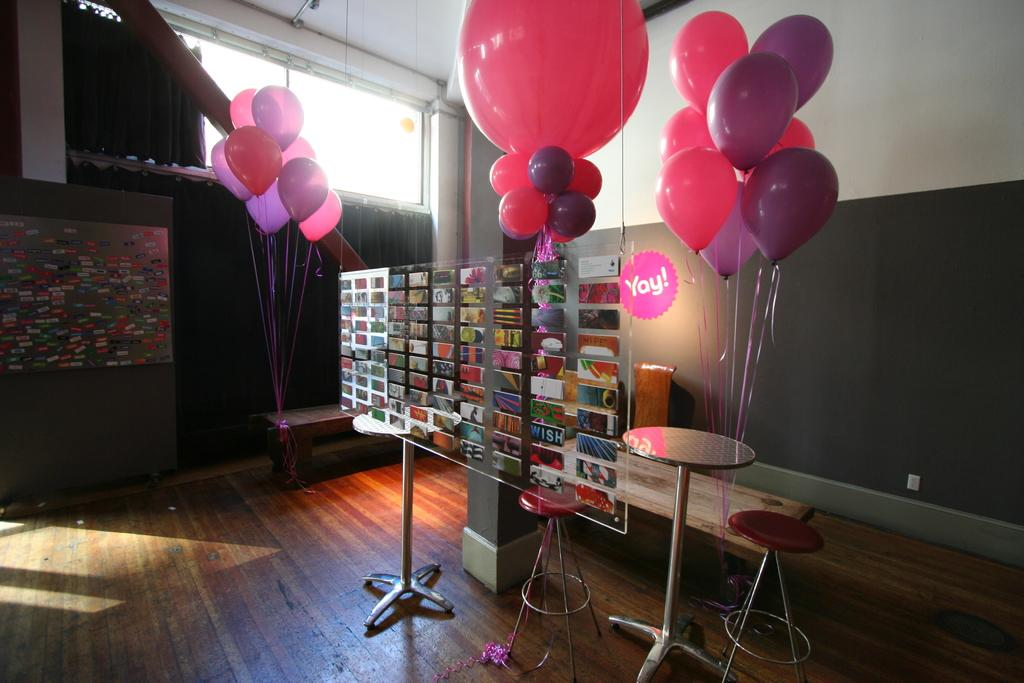Provide a one-sentence caption for the provided image. Pink and purple balloons decorate a room with a yay sign hanging up. 